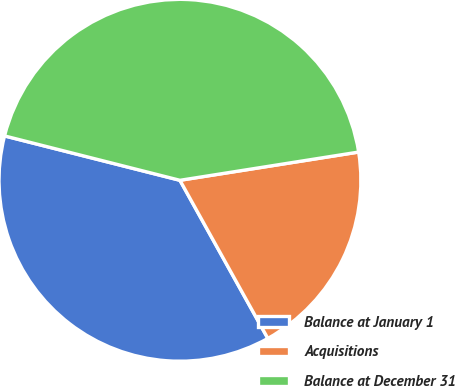Convert chart to OTSL. <chart><loc_0><loc_0><loc_500><loc_500><pie_chart><fcel>Balance at January 1<fcel>Acquisitions<fcel>Balance at December 31<nl><fcel>37.02%<fcel>19.42%<fcel>43.56%<nl></chart> 